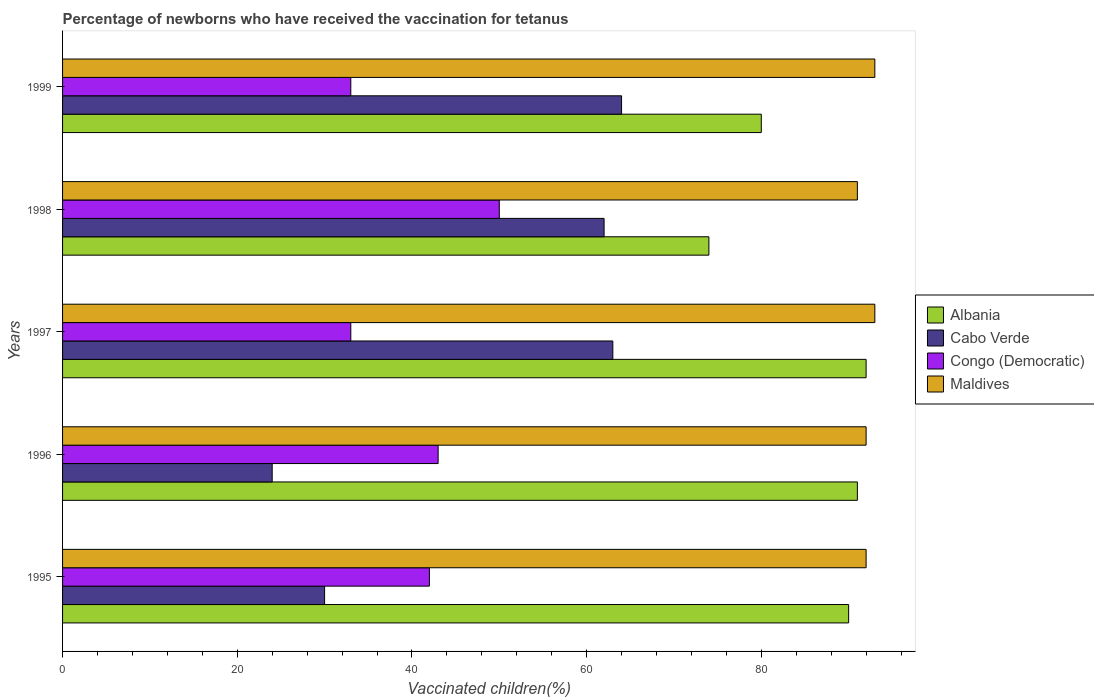How many different coloured bars are there?
Offer a terse response. 4. Are the number of bars on each tick of the Y-axis equal?
Keep it short and to the point. Yes. What is the label of the 5th group of bars from the top?
Keep it short and to the point. 1995. In how many cases, is the number of bars for a given year not equal to the number of legend labels?
Ensure brevity in your answer.  0. Across all years, what is the minimum percentage of vaccinated children in Congo (Democratic)?
Provide a short and direct response. 33. In which year was the percentage of vaccinated children in Cabo Verde minimum?
Ensure brevity in your answer.  1996. What is the total percentage of vaccinated children in Cabo Verde in the graph?
Make the answer very short. 243. What is the difference between the percentage of vaccinated children in Congo (Democratic) in 1997 and the percentage of vaccinated children in Cabo Verde in 1999?
Give a very brief answer. -31. What is the average percentage of vaccinated children in Albania per year?
Your response must be concise. 85.4. What is the ratio of the percentage of vaccinated children in Maldives in 1996 to that in 1997?
Provide a succinct answer. 0.99. Is the percentage of vaccinated children in Albania in 1995 less than that in 1999?
Your answer should be compact. No. What is the difference between the highest and the second highest percentage of vaccinated children in Cabo Verde?
Make the answer very short. 1. Is the sum of the percentage of vaccinated children in Cabo Verde in 1996 and 1998 greater than the maximum percentage of vaccinated children in Congo (Democratic) across all years?
Your answer should be compact. Yes. Is it the case that in every year, the sum of the percentage of vaccinated children in Albania and percentage of vaccinated children in Cabo Verde is greater than the sum of percentage of vaccinated children in Congo (Democratic) and percentage of vaccinated children in Maldives?
Your answer should be very brief. Yes. What does the 3rd bar from the top in 1995 represents?
Keep it short and to the point. Cabo Verde. What does the 3rd bar from the bottom in 1995 represents?
Keep it short and to the point. Congo (Democratic). Does the graph contain any zero values?
Your answer should be very brief. No. Does the graph contain grids?
Offer a very short reply. No. Where does the legend appear in the graph?
Offer a very short reply. Center right. How many legend labels are there?
Make the answer very short. 4. What is the title of the graph?
Offer a terse response. Percentage of newborns who have received the vaccination for tetanus. What is the label or title of the X-axis?
Make the answer very short. Vaccinated children(%). What is the label or title of the Y-axis?
Your response must be concise. Years. What is the Vaccinated children(%) of Albania in 1995?
Offer a very short reply. 90. What is the Vaccinated children(%) in Cabo Verde in 1995?
Provide a succinct answer. 30. What is the Vaccinated children(%) in Congo (Democratic) in 1995?
Keep it short and to the point. 42. What is the Vaccinated children(%) in Maldives in 1995?
Your response must be concise. 92. What is the Vaccinated children(%) of Albania in 1996?
Make the answer very short. 91. What is the Vaccinated children(%) in Cabo Verde in 1996?
Give a very brief answer. 24. What is the Vaccinated children(%) in Maldives in 1996?
Make the answer very short. 92. What is the Vaccinated children(%) in Albania in 1997?
Provide a succinct answer. 92. What is the Vaccinated children(%) of Cabo Verde in 1997?
Your response must be concise. 63. What is the Vaccinated children(%) in Congo (Democratic) in 1997?
Provide a succinct answer. 33. What is the Vaccinated children(%) in Maldives in 1997?
Your answer should be very brief. 93. What is the Vaccinated children(%) in Maldives in 1998?
Your answer should be compact. 91. What is the Vaccinated children(%) of Maldives in 1999?
Ensure brevity in your answer.  93. Across all years, what is the maximum Vaccinated children(%) in Albania?
Your answer should be very brief. 92. Across all years, what is the maximum Vaccinated children(%) in Cabo Verde?
Keep it short and to the point. 64. Across all years, what is the maximum Vaccinated children(%) in Congo (Democratic)?
Provide a short and direct response. 50. Across all years, what is the maximum Vaccinated children(%) in Maldives?
Your response must be concise. 93. Across all years, what is the minimum Vaccinated children(%) of Albania?
Provide a short and direct response. 74. Across all years, what is the minimum Vaccinated children(%) of Cabo Verde?
Your answer should be compact. 24. Across all years, what is the minimum Vaccinated children(%) in Congo (Democratic)?
Ensure brevity in your answer.  33. Across all years, what is the minimum Vaccinated children(%) in Maldives?
Give a very brief answer. 91. What is the total Vaccinated children(%) in Albania in the graph?
Offer a terse response. 427. What is the total Vaccinated children(%) of Cabo Verde in the graph?
Make the answer very short. 243. What is the total Vaccinated children(%) in Congo (Democratic) in the graph?
Make the answer very short. 201. What is the total Vaccinated children(%) of Maldives in the graph?
Keep it short and to the point. 461. What is the difference between the Vaccinated children(%) in Albania in 1995 and that in 1996?
Offer a terse response. -1. What is the difference between the Vaccinated children(%) in Cabo Verde in 1995 and that in 1996?
Keep it short and to the point. 6. What is the difference between the Vaccinated children(%) in Congo (Democratic) in 1995 and that in 1996?
Offer a terse response. -1. What is the difference between the Vaccinated children(%) in Cabo Verde in 1995 and that in 1997?
Give a very brief answer. -33. What is the difference between the Vaccinated children(%) in Congo (Democratic) in 1995 and that in 1997?
Give a very brief answer. 9. What is the difference between the Vaccinated children(%) in Albania in 1995 and that in 1998?
Ensure brevity in your answer.  16. What is the difference between the Vaccinated children(%) of Cabo Verde in 1995 and that in 1998?
Your answer should be very brief. -32. What is the difference between the Vaccinated children(%) of Congo (Democratic) in 1995 and that in 1998?
Ensure brevity in your answer.  -8. What is the difference between the Vaccinated children(%) in Maldives in 1995 and that in 1998?
Make the answer very short. 1. What is the difference between the Vaccinated children(%) of Albania in 1995 and that in 1999?
Offer a very short reply. 10. What is the difference between the Vaccinated children(%) in Cabo Verde in 1995 and that in 1999?
Your answer should be compact. -34. What is the difference between the Vaccinated children(%) in Congo (Democratic) in 1995 and that in 1999?
Your answer should be very brief. 9. What is the difference between the Vaccinated children(%) in Cabo Verde in 1996 and that in 1997?
Offer a very short reply. -39. What is the difference between the Vaccinated children(%) in Maldives in 1996 and that in 1997?
Give a very brief answer. -1. What is the difference between the Vaccinated children(%) in Cabo Verde in 1996 and that in 1998?
Your answer should be compact. -38. What is the difference between the Vaccinated children(%) of Maldives in 1996 and that in 1998?
Offer a very short reply. 1. What is the difference between the Vaccinated children(%) in Albania in 1996 and that in 1999?
Keep it short and to the point. 11. What is the difference between the Vaccinated children(%) of Albania in 1997 and that in 1998?
Offer a very short reply. 18. What is the difference between the Vaccinated children(%) of Maldives in 1997 and that in 1998?
Ensure brevity in your answer.  2. What is the difference between the Vaccinated children(%) of Albania in 1997 and that in 1999?
Your answer should be very brief. 12. What is the difference between the Vaccinated children(%) of Congo (Democratic) in 1997 and that in 1999?
Ensure brevity in your answer.  0. What is the difference between the Vaccinated children(%) of Cabo Verde in 1998 and that in 1999?
Ensure brevity in your answer.  -2. What is the difference between the Vaccinated children(%) in Albania in 1995 and the Vaccinated children(%) in Cabo Verde in 1996?
Give a very brief answer. 66. What is the difference between the Vaccinated children(%) in Albania in 1995 and the Vaccinated children(%) in Maldives in 1996?
Keep it short and to the point. -2. What is the difference between the Vaccinated children(%) in Cabo Verde in 1995 and the Vaccinated children(%) in Congo (Democratic) in 1996?
Ensure brevity in your answer.  -13. What is the difference between the Vaccinated children(%) in Cabo Verde in 1995 and the Vaccinated children(%) in Maldives in 1996?
Keep it short and to the point. -62. What is the difference between the Vaccinated children(%) in Albania in 1995 and the Vaccinated children(%) in Cabo Verde in 1997?
Offer a terse response. 27. What is the difference between the Vaccinated children(%) in Cabo Verde in 1995 and the Vaccinated children(%) in Maldives in 1997?
Make the answer very short. -63. What is the difference between the Vaccinated children(%) in Congo (Democratic) in 1995 and the Vaccinated children(%) in Maldives in 1997?
Keep it short and to the point. -51. What is the difference between the Vaccinated children(%) in Cabo Verde in 1995 and the Vaccinated children(%) in Maldives in 1998?
Give a very brief answer. -61. What is the difference between the Vaccinated children(%) in Congo (Democratic) in 1995 and the Vaccinated children(%) in Maldives in 1998?
Offer a terse response. -49. What is the difference between the Vaccinated children(%) in Cabo Verde in 1995 and the Vaccinated children(%) in Maldives in 1999?
Your response must be concise. -63. What is the difference between the Vaccinated children(%) of Congo (Democratic) in 1995 and the Vaccinated children(%) of Maldives in 1999?
Give a very brief answer. -51. What is the difference between the Vaccinated children(%) of Albania in 1996 and the Vaccinated children(%) of Cabo Verde in 1997?
Keep it short and to the point. 28. What is the difference between the Vaccinated children(%) in Cabo Verde in 1996 and the Vaccinated children(%) in Maldives in 1997?
Offer a very short reply. -69. What is the difference between the Vaccinated children(%) in Albania in 1996 and the Vaccinated children(%) in Cabo Verde in 1998?
Provide a short and direct response. 29. What is the difference between the Vaccinated children(%) of Albania in 1996 and the Vaccinated children(%) of Maldives in 1998?
Your answer should be very brief. 0. What is the difference between the Vaccinated children(%) of Cabo Verde in 1996 and the Vaccinated children(%) of Maldives in 1998?
Your response must be concise. -67. What is the difference between the Vaccinated children(%) of Congo (Democratic) in 1996 and the Vaccinated children(%) of Maldives in 1998?
Keep it short and to the point. -48. What is the difference between the Vaccinated children(%) in Albania in 1996 and the Vaccinated children(%) in Cabo Verde in 1999?
Provide a succinct answer. 27. What is the difference between the Vaccinated children(%) in Cabo Verde in 1996 and the Vaccinated children(%) in Congo (Democratic) in 1999?
Offer a terse response. -9. What is the difference between the Vaccinated children(%) of Cabo Verde in 1996 and the Vaccinated children(%) of Maldives in 1999?
Your answer should be very brief. -69. What is the difference between the Vaccinated children(%) in Albania in 1997 and the Vaccinated children(%) in Cabo Verde in 1998?
Ensure brevity in your answer.  30. What is the difference between the Vaccinated children(%) of Albania in 1997 and the Vaccinated children(%) of Congo (Democratic) in 1998?
Your answer should be compact. 42. What is the difference between the Vaccinated children(%) of Albania in 1997 and the Vaccinated children(%) of Maldives in 1998?
Give a very brief answer. 1. What is the difference between the Vaccinated children(%) of Cabo Verde in 1997 and the Vaccinated children(%) of Maldives in 1998?
Ensure brevity in your answer.  -28. What is the difference between the Vaccinated children(%) in Congo (Democratic) in 1997 and the Vaccinated children(%) in Maldives in 1998?
Offer a terse response. -58. What is the difference between the Vaccinated children(%) of Albania in 1997 and the Vaccinated children(%) of Congo (Democratic) in 1999?
Ensure brevity in your answer.  59. What is the difference between the Vaccinated children(%) of Cabo Verde in 1997 and the Vaccinated children(%) of Congo (Democratic) in 1999?
Offer a very short reply. 30. What is the difference between the Vaccinated children(%) in Congo (Democratic) in 1997 and the Vaccinated children(%) in Maldives in 1999?
Ensure brevity in your answer.  -60. What is the difference between the Vaccinated children(%) in Albania in 1998 and the Vaccinated children(%) in Congo (Democratic) in 1999?
Your answer should be very brief. 41. What is the difference between the Vaccinated children(%) of Cabo Verde in 1998 and the Vaccinated children(%) of Congo (Democratic) in 1999?
Offer a very short reply. 29. What is the difference between the Vaccinated children(%) in Cabo Verde in 1998 and the Vaccinated children(%) in Maldives in 1999?
Ensure brevity in your answer.  -31. What is the difference between the Vaccinated children(%) in Congo (Democratic) in 1998 and the Vaccinated children(%) in Maldives in 1999?
Your answer should be very brief. -43. What is the average Vaccinated children(%) of Albania per year?
Your answer should be very brief. 85.4. What is the average Vaccinated children(%) of Cabo Verde per year?
Offer a very short reply. 48.6. What is the average Vaccinated children(%) in Congo (Democratic) per year?
Ensure brevity in your answer.  40.2. What is the average Vaccinated children(%) in Maldives per year?
Keep it short and to the point. 92.2. In the year 1995, what is the difference between the Vaccinated children(%) of Albania and Vaccinated children(%) of Cabo Verde?
Make the answer very short. 60. In the year 1995, what is the difference between the Vaccinated children(%) in Albania and Vaccinated children(%) in Congo (Democratic)?
Give a very brief answer. 48. In the year 1995, what is the difference between the Vaccinated children(%) in Cabo Verde and Vaccinated children(%) in Maldives?
Your response must be concise. -62. In the year 1996, what is the difference between the Vaccinated children(%) of Albania and Vaccinated children(%) of Cabo Verde?
Your answer should be compact. 67. In the year 1996, what is the difference between the Vaccinated children(%) in Albania and Vaccinated children(%) in Maldives?
Keep it short and to the point. -1. In the year 1996, what is the difference between the Vaccinated children(%) in Cabo Verde and Vaccinated children(%) in Maldives?
Your answer should be compact. -68. In the year 1996, what is the difference between the Vaccinated children(%) in Congo (Democratic) and Vaccinated children(%) in Maldives?
Your response must be concise. -49. In the year 1997, what is the difference between the Vaccinated children(%) of Albania and Vaccinated children(%) of Cabo Verde?
Provide a short and direct response. 29. In the year 1997, what is the difference between the Vaccinated children(%) in Albania and Vaccinated children(%) in Congo (Democratic)?
Offer a very short reply. 59. In the year 1997, what is the difference between the Vaccinated children(%) of Albania and Vaccinated children(%) of Maldives?
Your response must be concise. -1. In the year 1997, what is the difference between the Vaccinated children(%) in Cabo Verde and Vaccinated children(%) in Congo (Democratic)?
Keep it short and to the point. 30. In the year 1997, what is the difference between the Vaccinated children(%) of Cabo Verde and Vaccinated children(%) of Maldives?
Offer a very short reply. -30. In the year 1997, what is the difference between the Vaccinated children(%) of Congo (Democratic) and Vaccinated children(%) of Maldives?
Offer a very short reply. -60. In the year 1998, what is the difference between the Vaccinated children(%) in Albania and Vaccinated children(%) in Cabo Verde?
Your response must be concise. 12. In the year 1998, what is the difference between the Vaccinated children(%) of Albania and Vaccinated children(%) of Maldives?
Offer a terse response. -17. In the year 1998, what is the difference between the Vaccinated children(%) of Congo (Democratic) and Vaccinated children(%) of Maldives?
Make the answer very short. -41. In the year 1999, what is the difference between the Vaccinated children(%) in Albania and Vaccinated children(%) in Cabo Verde?
Ensure brevity in your answer.  16. In the year 1999, what is the difference between the Vaccinated children(%) in Cabo Verde and Vaccinated children(%) in Congo (Democratic)?
Your response must be concise. 31. In the year 1999, what is the difference between the Vaccinated children(%) in Cabo Verde and Vaccinated children(%) in Maldives?
Provide a short and direct response. -29. In the year 1999, what is the difference between the Vaccinated children(%) in Congo (Democratic) and Vaccinated children(%) in Maldives?
Make the answer very short. -60. What is the ratio of the Vaccinated children(%) in Albania in 1995 to that in 1996?
Ensure brevity in your answer.  0.99. What is the ratio of the Vaccinated children(%) of Cabo Verde in 1995 to that in 1996?
Your response must be concise. 1.25. What is the ratio of the Vaccinated children(%) of Congo (Democratic) in 1995 to that in 1996?
Offer a terse response. 0.98. What is the ratio of the Vaccinated children(%) in Albania in 1995 to that in 1997?
Your response must be concise. 0.98. What is the ratio of the Vaccinated children(%) of Cabo Verde in 1995 to that in 1997?
Ensure brevity in your answer.  0.48. What is the ratio of the Vaccinated children(%) in Congo (Democratic) in 1995 to that in 1997?
Ensure brevity in your answer.  1.27. What is the ratio of the Vaccinated children(%) in Albania in 1995 to that in 1998?
Provide a short and direct response. 1.22. What is the ratio of the Vaccinated children(%) of Cabo Verde in 1995 to that in 1998?
Your answer should be compact. 0.48. What is the ratio of the Vaccinated children(%) in Congo (Democratic) in 1995 to that in 1998?
Keep it short and to the point. 0.84. What is the ratio of the Vaccinated children(%) in Maldives in 1995 to that in 1998?
Give a very brief answer. 1.01. What is the ratio of the Vaccinated children(%) of Albania in 1995 to that in 1999?
Your response must be concise. 1.12. What is the ratio of the Vaccinated children(%) in Cabo Verde in 1995 to that in 1999?
Offer a very short reply. 0.47. What is the ratio of the Vaccinated children(%) of Congo (Democratic) in 1995 to that in 1999?
Your response must be concise. 1.27. What is the ratio of the Vaccinated children(%) of Maldives in 1995 to that in 1999?
Offer a very short reply. 0.99. What is the ratio of the Vaccinated children(%) in Albania in 1996 to that in 1997?
Keep it short and to the point. 0.99. What is the ratio of the Vaccinated children(%) of Cabo Verde in 1996 to that in 1997?
Your response must be concise. 0.38. What is the ratio of the Vaccinated children(%) of Congo (Democratic) in 1996 to that in 1997?
Give a very brief answer. 1.3. What is the ratio of the Vaccinated children(%) of Maldives in 1996 to that in 1997?
Keep it short and to the point. 0.99. What is the ratio of the Vaccinated children(%) in Albania in 1996 to that in 1998?
Offer a terse response. 1.23. What is the ratio of the Vaccinated children(%) in Cabo Verde in 1996 to that in 1998?
Provide a short and direct response. 0.39. What is the ratio of the Vaccinated children(%) of Congo (Democratic) in 1996 to that in 1998?
Your answer should be very brief. 0.86. What is the ratio of the Vaccinated children(%) of Maldives in 1996 to that in 1998?
Provide a short and direct response. 1.01. What is the ratio of the Vaccinated children(%) in Albania in 1996 to that in 1999?
Your answer should be compact. 1.14. What is the ratio of the Vaccinated children(%) of Congo (Democratic) in 1996 to that in 1999?
Keep it short and to the point. 1.3. What is the ratio of the Vaccinated children(%) in Maldives in 1996 to that in 1999?
Ensure brevity in your answer.  0.99. What is the ratio of the Vaccinated children(%) of Albania in 1997 to that in 1998?
Your answer should be compact. 1.24. What is the ratio of the Vaccinated children(%) of Cabo Verde in 1997 to that in 1998?
Your response must be concise. 1.02. What is the ratio of the Vaccinated children(%) in Congo (Democratic) in 1997 to that in 1998?
Keep it short and to the point. 0.66. What is the ratio of the Vaccinated children(%) in Maldives in 1997 to that in 1998?
Your response must be concise. 1.02. What is the ratio of the Vaccinated children(%) of Albania in 1997 to that in 1999?
Provide a short and direct response. 1.15. What is the ratio of the Vaccinated children(%) in Cabo Verde in 1997 to that in 1999?
Your response must be concise. 0.98. What is the ratio of the Vaccinated children(%) of Albania in 1998 to that in 1999?
Offer a very short reply. 0.93. What is the ratio of the Vaccinated children(%) in Cabo Verde in 1998 to that in 1999?
Your answer should be very brief. 0.97. What is the ratio of the Vaccinated children(%) of Congo (Democratic) in 1998 to that in 1999?
Your answer should be very brief. 1.52. What is the ratio of the Vaccinated children(%) in Maldives in 1998 to that in 1999?
Ensure brevity in your answer.  0.98. What is the difference between the highest and the second highest Vaccinated children(%) in Cabo Verde?
Provide a succinct answer. 1. What is the difference between the highest and the second highest Vaccinated children(%) in Maldives?
Give a very brief answer. 0. What is the difference between the highest and the lowest Vaccinated children(%) of Albania?
Provide a succinct answer. 18. 